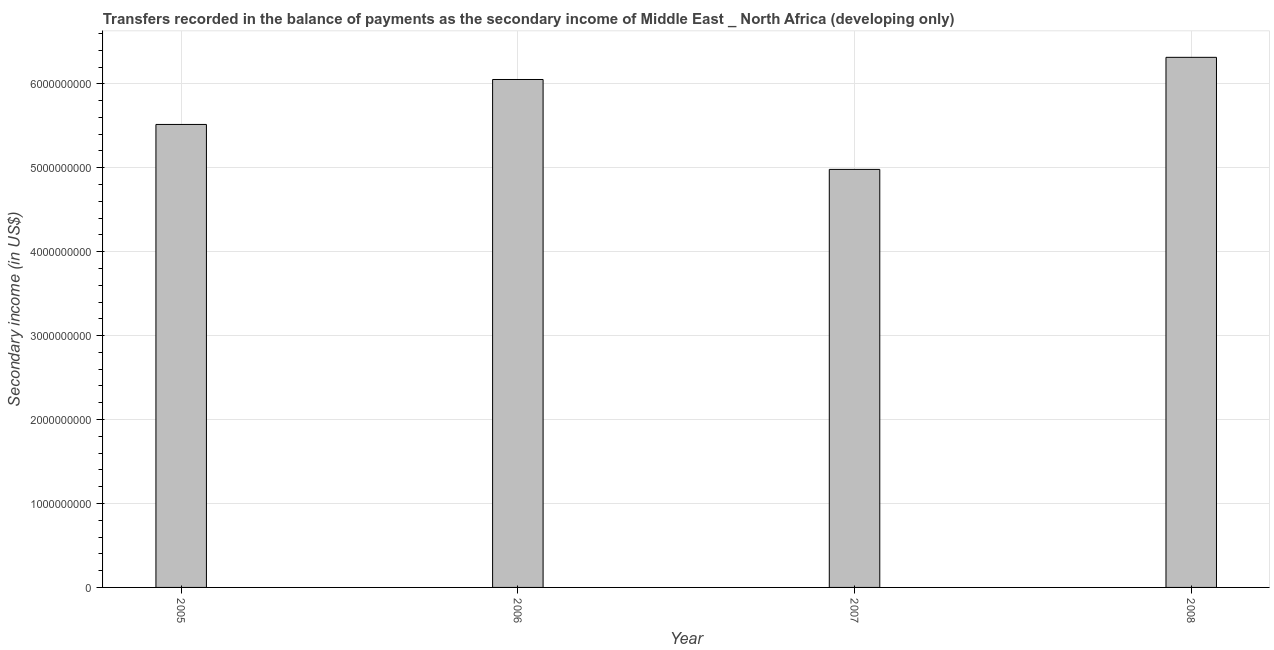Does the graph contain grids?
Provide a short and direct response. Yes. What is the title of the graph?
Offer a terse response. Transfers recorded in the balance of payments as the secondary income of Middle East _ North Africa (developing only). What is the label or title of the Y-axis?
Make the answer very short. Secondary income (in US$). What is the amount of secondary income in 2006?
Provide a short and direct response. 6.05e+09. Across all years, what is the maximum amount of secondary income?
Keep it short and to the point. 6.32e+09. Across all years, what is the minimum amount of secondary income?
Provide a short and direct response. 4.98e+09. In which year was the amount of secondary income maximum?
Offer a terse response. 2008. What is the sum of the amount of secondary income?
Keep it short and to the point. 2.29e+1. What is the difference between the amount of secondary income in 2005 and 2006?
Ensure brevity in your answer.  -5.36e+08. What is the average amount of secondary income per year?
Give a very brief answer. 5.72e+09. What is the median amount of secondary income?
Your response must be concise. 5.78e+09. In how many years, is the amount of secondary income greater than 1800000000 US$?
Give a very brief answer. 4. Do a majority of the years between 2006 and 2005 (inclusive) have amount of secondary income greater than 5200000000 US$?
Offer a very short reply. No. What is the ratio of the amount of secondary income in 2005 to that in 2007?
Make the answer very short. 1.11. Is the difference between the amount of secondary income in 2005 and 2008 greater than the difference between any two years?
Your answer should be compact. No. What is the difference between the highest and the second highest amount of secondary income?
Provide a short and direct response. 2.64e+08. Is the sum of the amount of secondary income in 2005 and 2007 greater than the maximum amount of secondary income across all years?
Provide a short and direct response. Yes. What is the difference between the highest and the lowest amount of secondary income?
Your response must be concise. 1.34e+09. Are the values on the major ticks of Y-axis written in scientific E-notation?
Keep it short and to the point. No. What is the Secondary income (in US$) in 2005?
Your answer should be very brief. 5.52e+09. What is the Secondary income (in US$) in 2006?
Give a very brief answer. 6.05e+09. What is the Secondary income (in US$) in 2007?
Provide a succinct answer. 4.98e+09. What is the Secondary income (in US$) of 2008?
Your response must be concise. 6.32e+09. What is the difference between the Secondary income (in US$) in 2005 and 2006?
Give a very brief answer. -5.36e+08. What is the difference between the Secondary income (in US$) in 2005 and 2007?
Your answer should be very brief. 5.36e+08. What is the difference between the Secondary income (in US$) in 2005 and 2008?
Give a very brief answer. -8.00e+08. What is the difference between the Secondary income (in US$) in 2006 and 2007?
Keep it short and to the point. 1.07e+09. What is the difference between the Secondary income (in US$) in 2006 and 2008?
Offer a very short reply. -2.64e+08. What is the difference between the Secondary income (in US$) in 2007 and 2008?
Your response must be concise. -1.34e+09. What is the ratio of the Secondary income (in US$) in 2005 to that in 2006?
Your response must be concise. 0.91. What is the ratio of the Secondary income (in US$) in 2005 to that in 2007?
Your answer should be compact. 1.11. What is the ratio of the Secondary income (in US$) in 2005 to that in 2008?
Your answer should be very brief. 0.87. What is the ratio of the Secondary income (in US$) in 2006 to that in 2007?
Ensure brevity in your answer.  1.22. What is the ratio of the Secondary income (in US$) in 2006 to that in 2008?
Keep it short and to the point. 0.96. What is the ratio of the Secondary income (in US$) in 2007 to that in 2008?
Your answer should be compact. 0.79. 